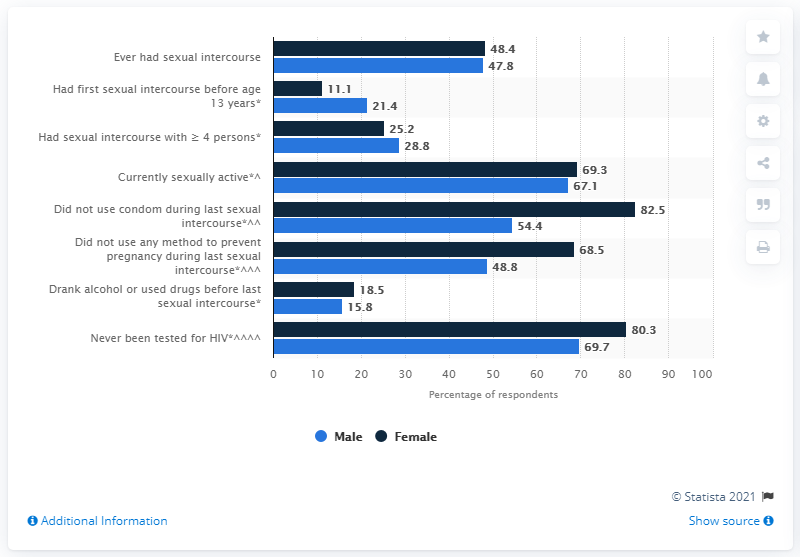Mention a couple of crucial points in this snapshot. In a survey of lesbian females, 11.1% reported that they had their first sexual intercourse before the age of 13. 